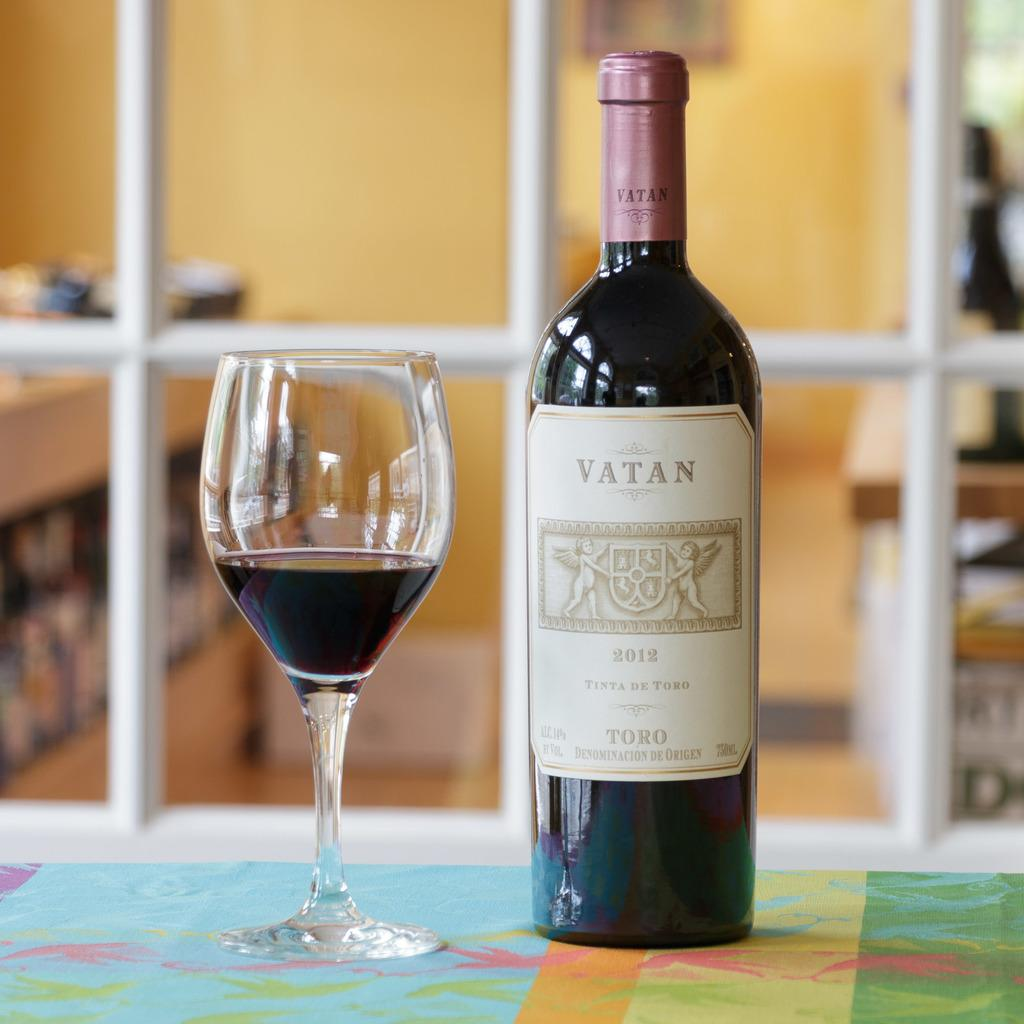Provide a one-sentence caption for the provided image. Bottle of Vatan Toro wine with a glass of wine. 